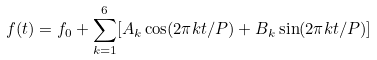<formula> <loc_0><loc_0><loc_500><loc_500>f ( t ) = f _ { 0 } + \sum _ { k = 1 } ^ { 6 } [ A _ { k } \cos ( 2 \pi k t / P ) + B _ { k } \sin ( 2 \pi k t / P ) ]</formula> 